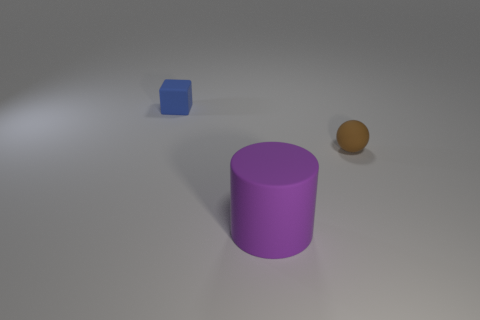Are there any big purple matte cylinders behind the brown rubber ball?
Ensure brevity in your answer.  No. Are there an equal number of rubber things that are behind the small matte cube and matte cylinders that are left of the large purple cylinder?
Keep it short and to the point. Yes. How many large blue metal spheres are there?
Provide a short and direct response. 0. Is the number of brown rubber balls to the left of the tiny rubber sphere greater than the number of big cyan cylinders?
Ensure brevity in your answer.  No. There is a tiny thing that is to the right of the cube; what is its material?
Offer a terse response. Rubber. How many big rubber cylinders have the same color as the small matte cube?
Your answer should be compact. 0. Does the thing that is on the left side of the big purple object have the same size as the thing to the right of the purple matte thing?
Make the answer very short. Yes. Is the size of the purple matte cylinder the same as the object that is right of the large purple cylinder?
Give a very brief answer. No. How big is the blue cube?
Offer a very short reply. Small. There is a sphere that is the same material as the small blue object; what is its color?
Keep it short and to the point. Brown. 